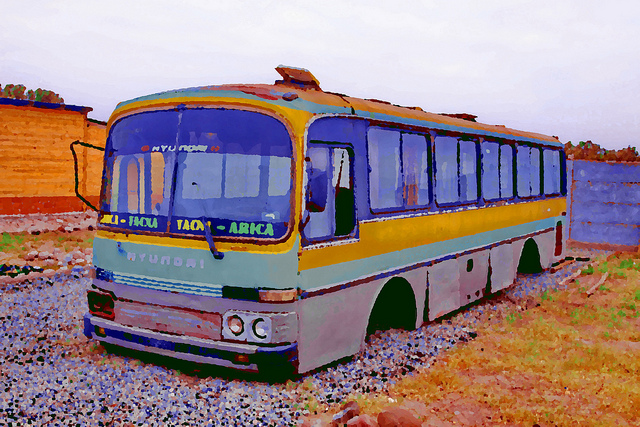Read all the text in this image. NTUNDAt 